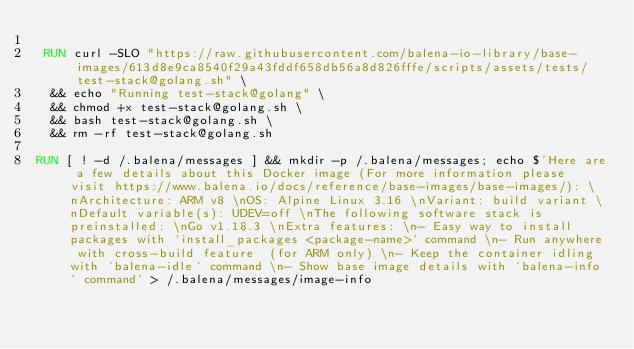<code> <loc_0><loc_0><loc_500><loc_500><_Dockerfile_>
 RUN curl -SLO "https://raw.githubusercontent.com/balena-io-library/base-images/613d8e9ca8540f29a43fddf658db56a8d826fffe/scripts/assets/tests/test-stack@golang.sh" \
  && echo "Running test-stack@golang" \
  && chmod +x test-stack@golang.sh \
  && bash test-stack@golang.sh \
  && rm -rf test-stack@golang.sh 

RUN [ ! -d /.balena/messages ] && mkdir -p /.balena/messages; echo $'Here are a few details about this Docker image (For more information please visit https://www.balena.io/docs/reference/base-images/base-images/): \nArchitecture: ARM v8 \nOS: Alpine Linux 3.16 \nVariant: build variant \nDefault variable(s): UDEV=off \nThe following software stack is preinstalled: \nGo v1.18.3 \nExtra features: \n- Easy way to install packages with `install_packages <package-name>` command \n- Run anywhere with cross-build feature  (for ARM only) \n- Keep the container idling with `balena-idle` command \n- Show base image details with `balena-info` command' > /.balena/messages/image-info</code> 